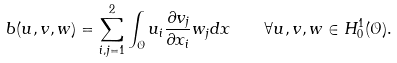<formula> <loc_0><loc_0><loc_500><loc_500>b ( u , v , w ) = \sum _ { i , j = 1 } ^ { 2 } \int _ { \mathcal { O } } u _ { i } \frac { \partial v _ { j } } { \partial x _ { i } } w _ { j } d x \quad \forall u , v , w \in H _ { 0 } ^ { 1 } ( \mathcal { O } ) .</formula> 